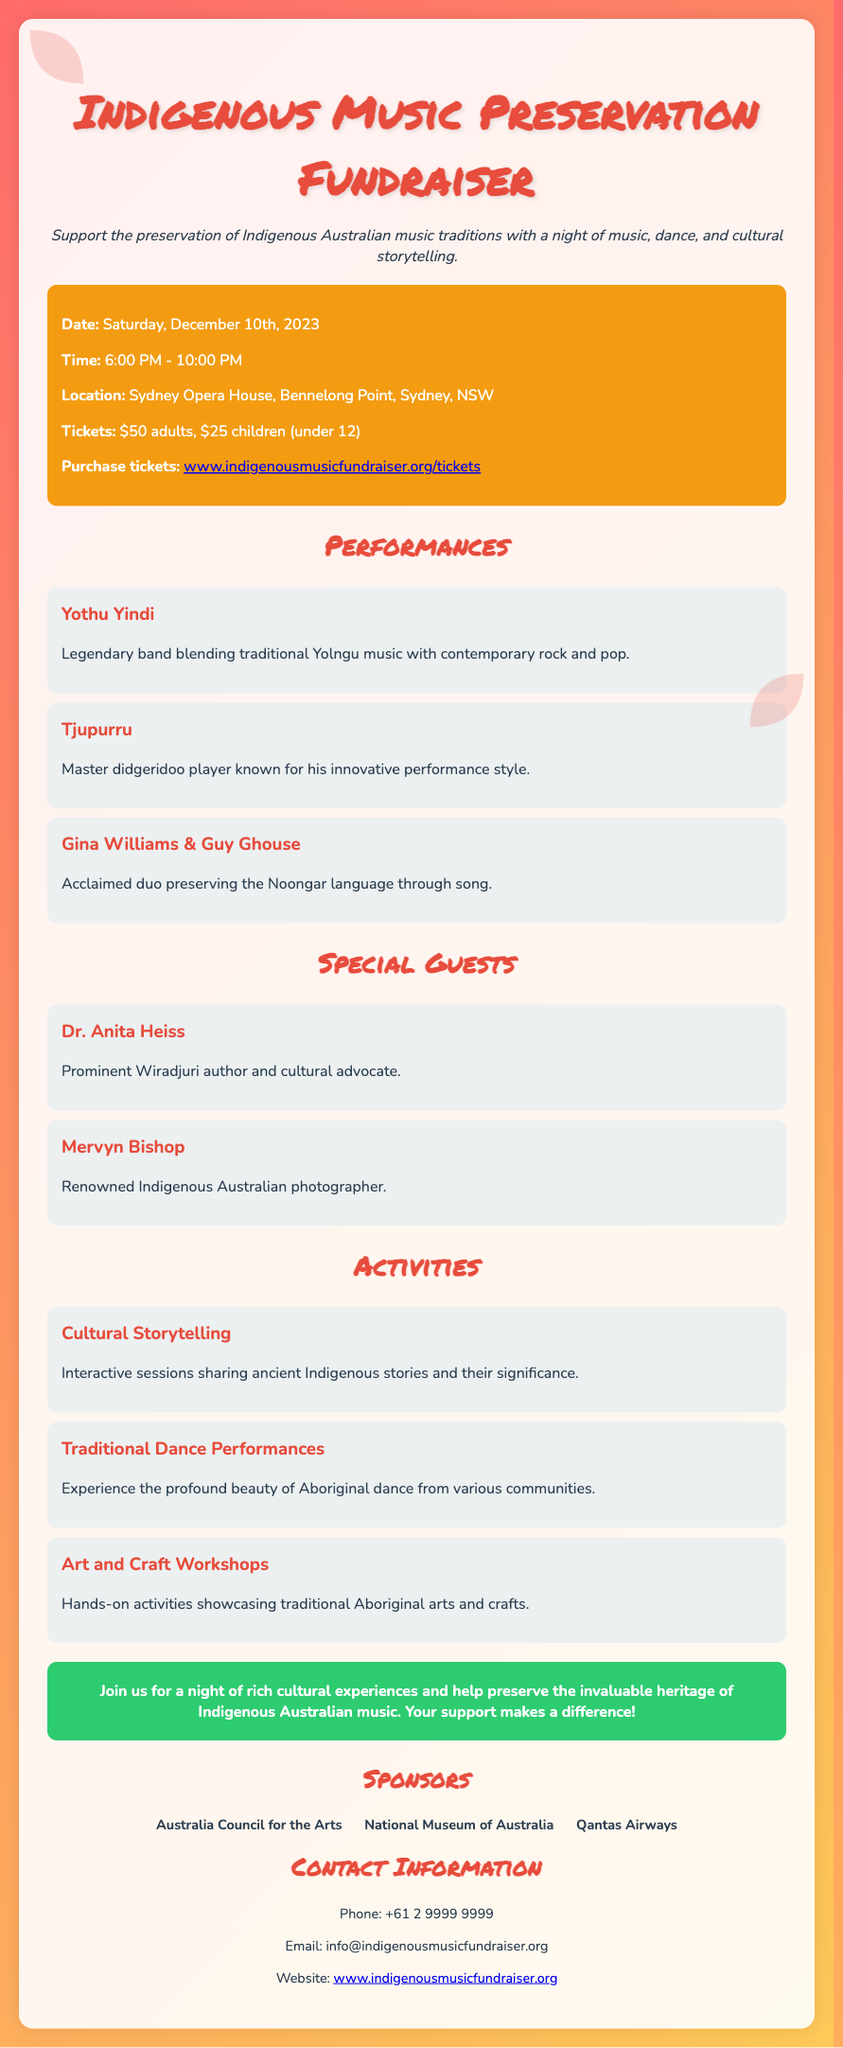What is the date of the event? The event is scheduled for Saturday, December 10th, 2023, as stated in the document.
Answer: December 10th, 2023 What time does the event start? The start time of the event is listed as 6:00 PM in the information section.
Answer: 6:00 PM What is the ticket price for adults? The flyer lists the ticket price for adults as $50.
Answer: $50 Who is the legendary band performing? The document mentions Yothu Yindi as a legendary band performing at the event.
Answer: Yothu Yindi Which author is a special guest? Dr. Anita Heiss is specifically mentioned as a prominent Wiradjuri author and cultural advocate.
Answer: Dr. Anita Heiss What type of activities are available? The flyer presents several activities including Cultural Storytelling, Traditional Dance Performances, and Art and Craft Workshops.
Answer: Cultural Storytelling, Traditional Dance Performances, Art and Craft Workshops How can tickets be purchased? The flyer provides a link for purchasing tickets to the event.
Answer: www.indigenousmusicfundraiser.org/tickets What kind of music does Tjupurru play? The document notes Tjupurru is known for his innovative performance style as a master didgeridoo player.
Answer: Didgeridoo Who sponsors the event? The document lists sponsors which include Australia Council for the Arts, National Museum of Australia, and Qantas Airways.
Answer: Australia Council for the Arts, National Museum of Australia, Qantas Airways 